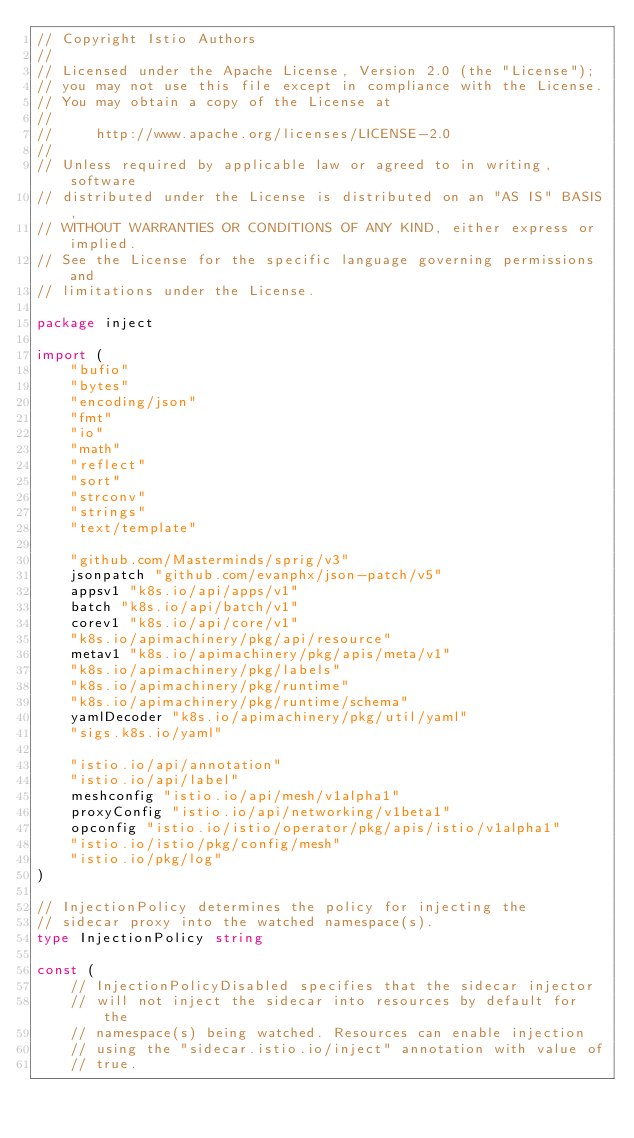<code> <loc_0><loc_0><loc_500><loc_500><_Go_>// Copyright Istio Authors
//
// Licensed under the Apache License, Version 2.0 (the "License");
// you may not use this file except in compliance with the License.
// You may obtain a copy of the License at
//
//     http://www.apache.org/licenses/LICENSE-2.0
//
// Unless required by applicable law or agreed to in writing, software
// distributed under the License is distributed on an "AS IS" BASIS,
// WITHOUT WARRANTIES OR CONDITIONS OF ANY KIND, either express or implied.
// See the License for the specific language governing permissions and
// limitations under the License.

package inject

import (
	"bufio"
	"bytes"
	"encoding/json"
	"fmt"
	"io"
	"math"
	"reflect"
	"sort"
	"strconv"
	"strings"
	"text/template"

	"github.com/Masterminds/sprig/v3"
	jsonpatch "github.com/evanphx/json-patch/v5"
	appsv1 "k8s.io/api/apps/v1"
	batch "k8s.io/api/batch/v1"
	corev1 "k8s.io/api/core/v1"
	"k8s.io/apimachinery/pkg/api/resource"
	metav1 "k8s.io/apimachinery/pkg/apis/meta/v1"
	"k8s.io/apimachinery/pkg/labels"
	"k8s.io/apimachinery/pkg/runtime"
	"k8s.io/apimachinery/pkg/runtime/schema"
	yamlDecoder "k8s.io/apimachinery/pkg/util/yaml"
	"sigs.k8s.io/yaml"

	"istio.io/api/annotation"
	"istio.io/api/label"
	meshconfig "istio.io/api/mesh/v1alpha1"
	proxyConfig "istio.io/api/networking/v1beta1"
	opconfig "istio.io/istio/operator/pkg/apis/istio/v1alpha1"
	"istio.io/istio/pkg/config/mesh"
	"istio.io/pkg/log"
)

// InjectionPolicy determines the policy for injecting the
// sidecar proxy into the watched namespace(s).
type InjectionPolicy string

const (
	// InjectionPolicyDisabled specifies that the sidecar injector
	// will not inject the sidecar into resources by default for the
	// namespace(s) being watched. Resources can enable injection
	// using the "sidecar.istio.io/inject" annotation with value of
	// true.</code> 